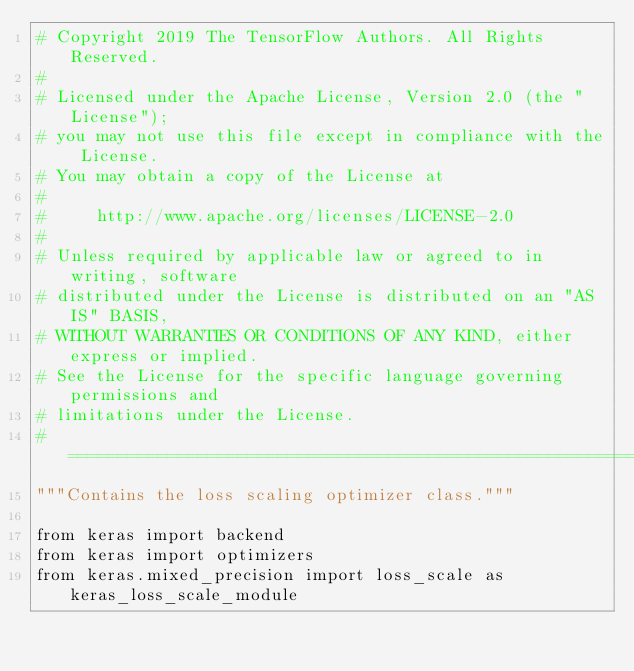<code> <loc_0><loc_0><loc_500><loc_500><_Python_># Copyright 2019 The TensorFlow Authors. All Rights Reserved.
#
# Licensed under the Apache License, Version 2.0 (the "License");
# you may not use this file except in compliance with the License.
# You may obtain a copy of the License at
#
#     http://www.apache.org/licenses/LICENSE-2.0
#
# Unless required by applicable law or agreed to in writing, software
# distributed under the License is distributed on an "AS IS" BASIS,
# WITHOUT WARRANTIES OR CONDITIONS OF ANY KIND, either express or implied.
# See the License for the specific language governing permissions and
# limitations under the License.
# ==============================================================================
"""Contains the loss scaling optimizer class."""

from keras import backend
from keras import optimizers
from keras.mixed_precision import loss_scale as keras_loss_scale_module</code> 